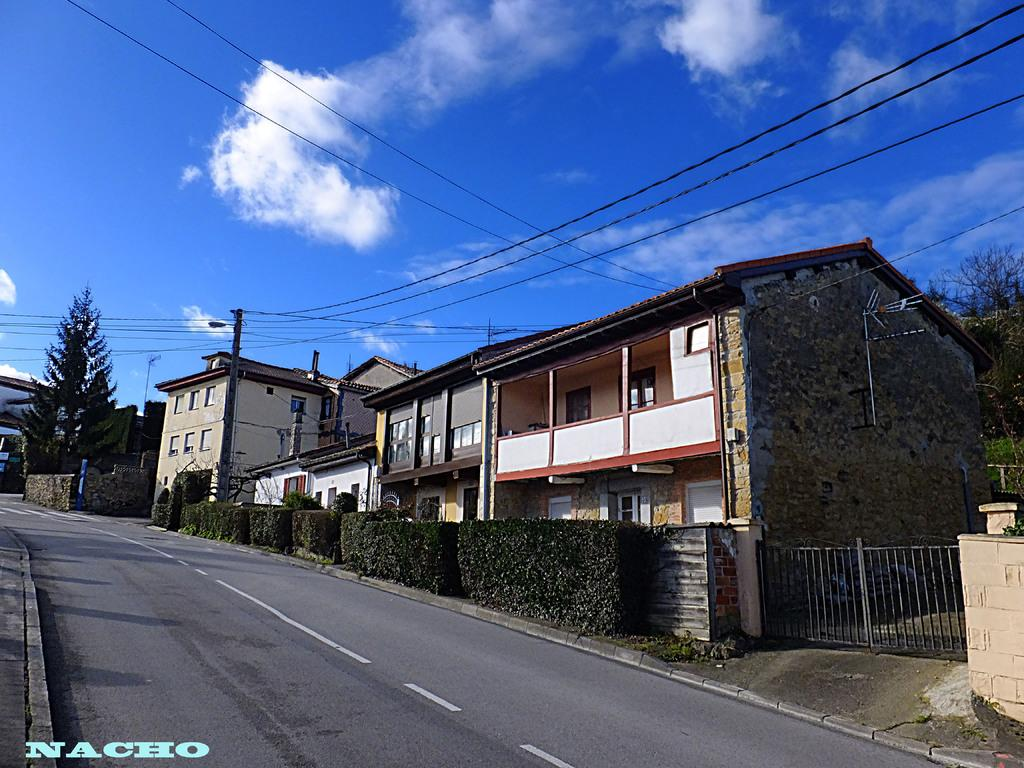<image>
Share a concise interpretation of the image provided. A photo bears the word Nacho in the bottom left corner. 